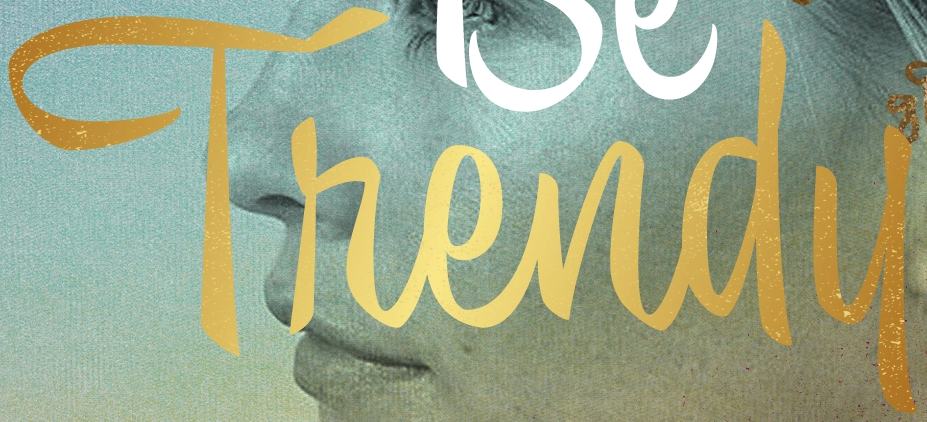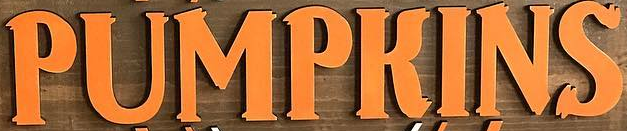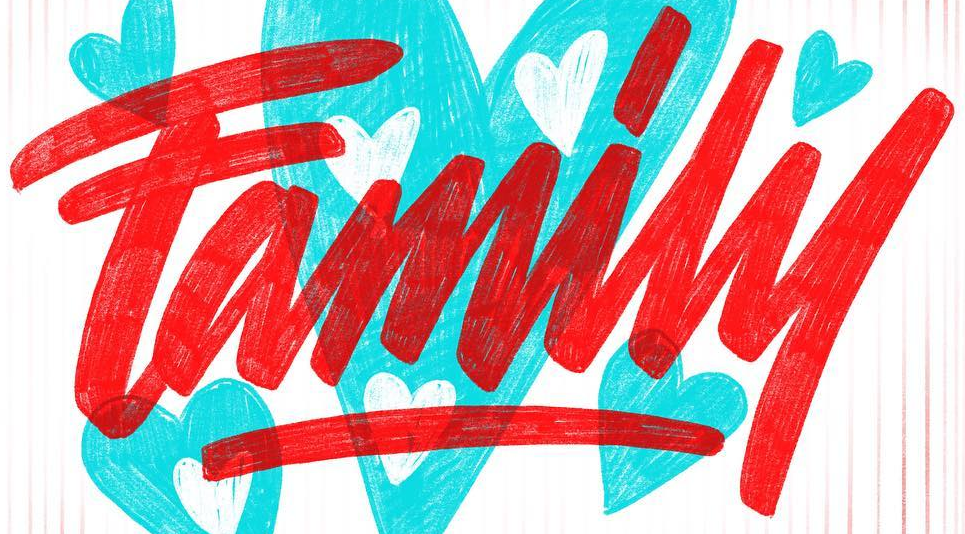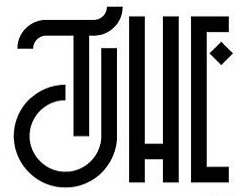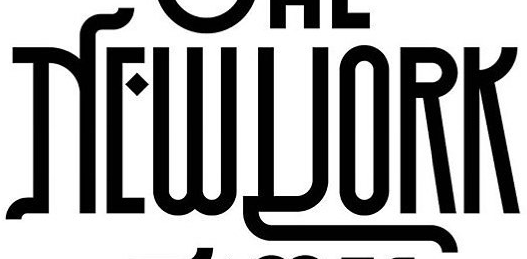What words can you see in these images in sequence, separated by a semicolon? Thendu; PUMPKINS; Family; THE; NEWYORK 